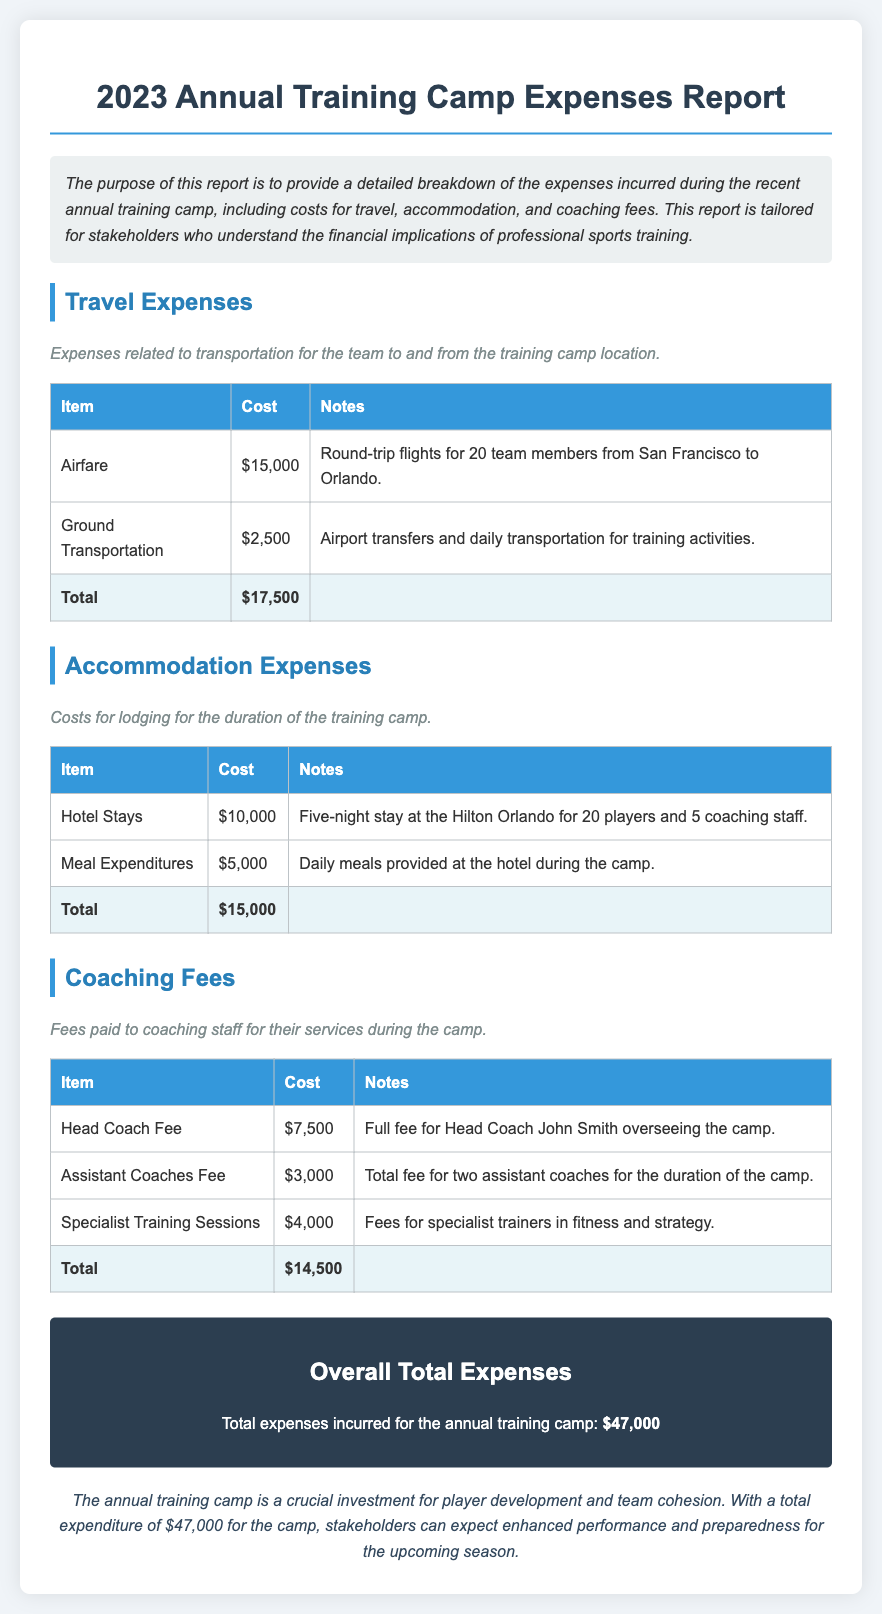what is the total travel expenses? The total travel expenses are calculated from the individual travel costs provided in the document, which are $15,000 (Airfare) + $2,500 (Ground Transportation) = $17,500.
Answer: $17,500 who was the head coach during the camp? The head coach, as mentioned in the document, is John Smith.
Answer: John Smith what is the accommodation amount for hotel stays? The document specifies the accommodation amount for hotel stays is $10,000 for a five-night stay.
Answer: $10,000 how many team members traveled to the training camp? The total number of team members traveling to the camp is stated to be 20, as mentioned in the airfare section.
Answer: 20 what is the total coaching fees? The total coaching fees are derived by adding all the coaching expenses: $7,500 (Head Coach) + $3,000 (Assistant Coaches) + $4,000 (Specialist Training) = $14,500.
Answer: $14,500 how much was spent on meal expenditures? The meal expenditures during the camp are clearly noted as $5,000 in the accommodation section of the report.
Answer: $5,000 what is the overall total expenses for the camp? The overall total expenses are clearly stated at the end of the report, summing all categories.
Answer: $47,000 what was the purpose of the report? The report outlines the purpose clearly, focusing on providing a breakdown of expenses incurred during the training camp.
Answer: breakdown of expenses how long was the training camp? The training camp lasted for five nights, as indicated in the accommodation section regarding hotel stays.
Answer: five nights 